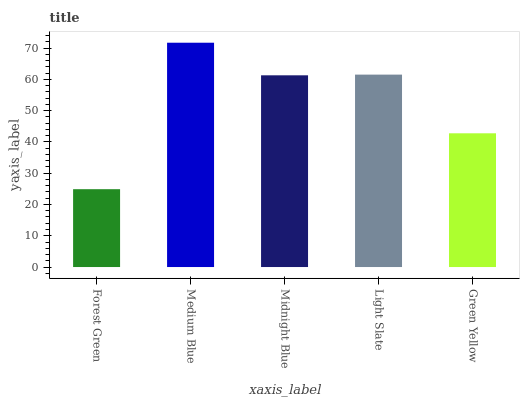Is Midnight Blue the minimum?
Answer yes or no. No. Is Midnight Blue the maximum?
Answer yes or no. No. Is Medium Blue greater than Midnight Blue?
Answer yes or no. Yes. Is Midnight Blue less than Medium Blue?
Answer yes or no. Yes. Is Midnight Blue greater than Medium Blue?
Answer yes or no. No. Is Medium Blue less than Midnight Blue?
Answer yes or no. No. Is Midnight Blue the high median?
Answer yes or no. Yes. Is Midnight Blue the low median?
Answer yes or no. Yes. Is Medium Blue the high median?
Answer yes or no. No. Is Light Slate the low median?
Answer yes or no. No. 